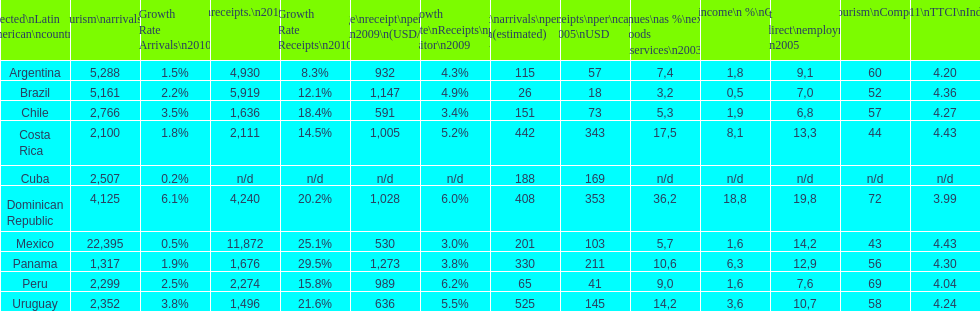Which nation tops the list in numerous classifications? Dominican Republic. 